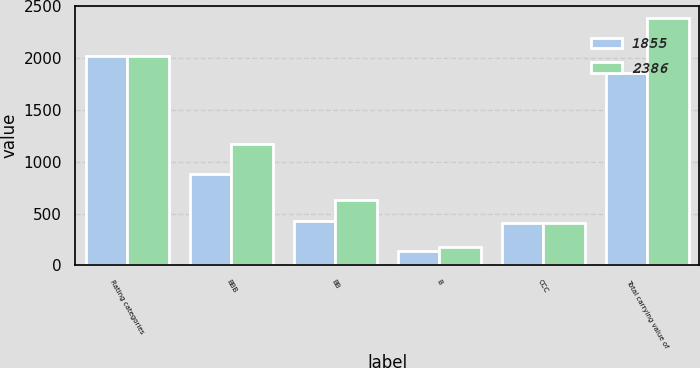<chart> <loc_0><loc_0><loc_500><loc_500><stacked_bar_chart><ecel><fcel>Rating categories<fcel>BBB<fcel>BB<fcel>B<fcel>CCC<fcel>Total carrying value of<nl><fcel>1855<fcel>2018<fcel>883<fcel>430<fcel>135<fcel>407<fcel>1855<nl><fcel>2386<fcel>2017<fcel>1170<fcel>627<fcel>177<fcel>412<fcel>2386<nl></chart> 